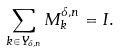<formula> <loc_0><loc_0><loc_500><loc_500>\sum _ { { k } \in Y _ { \delta , n } } M _ { k } ^ { \delta , n } = I .</formula> 